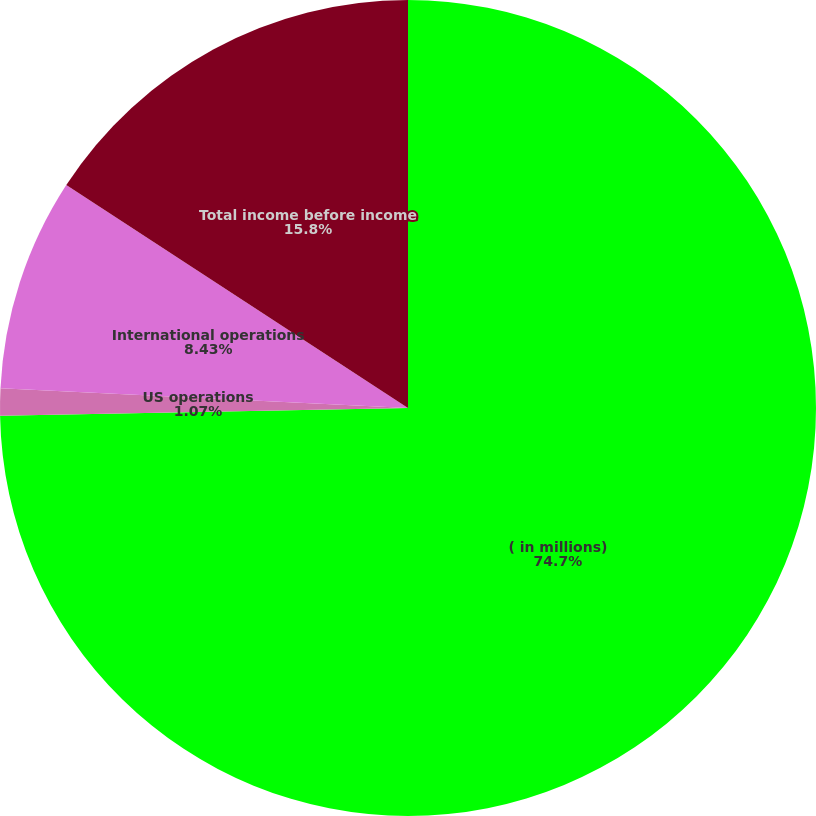Convert chart to OTSL. <chart><loc_0><loc_0><loc_500><loc_500><pie_chart><fcel>( in millions)<fcel>US operations<fcel>International operations<fcel>Total income before income<nl><fcel>74.7%<fcel>1.07%<fcel>8.43%<fcel>15.8%<nl></chart> 